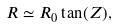Convert formula to latex. <formula><loc_0><loc_0><loc_500><loc_500>R \simeq R _ { 0 } \tan ( Z ) ,</formula> 